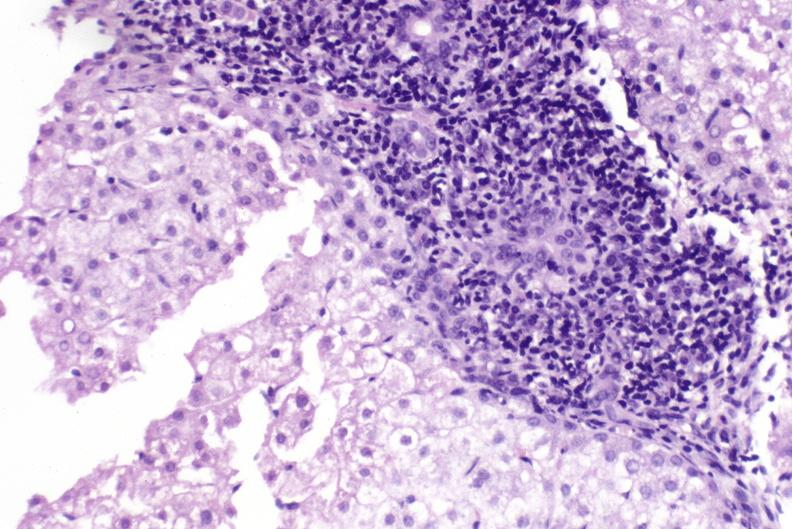s hepatobiliary present?
Answer the question using a single word or phrase. Yes 